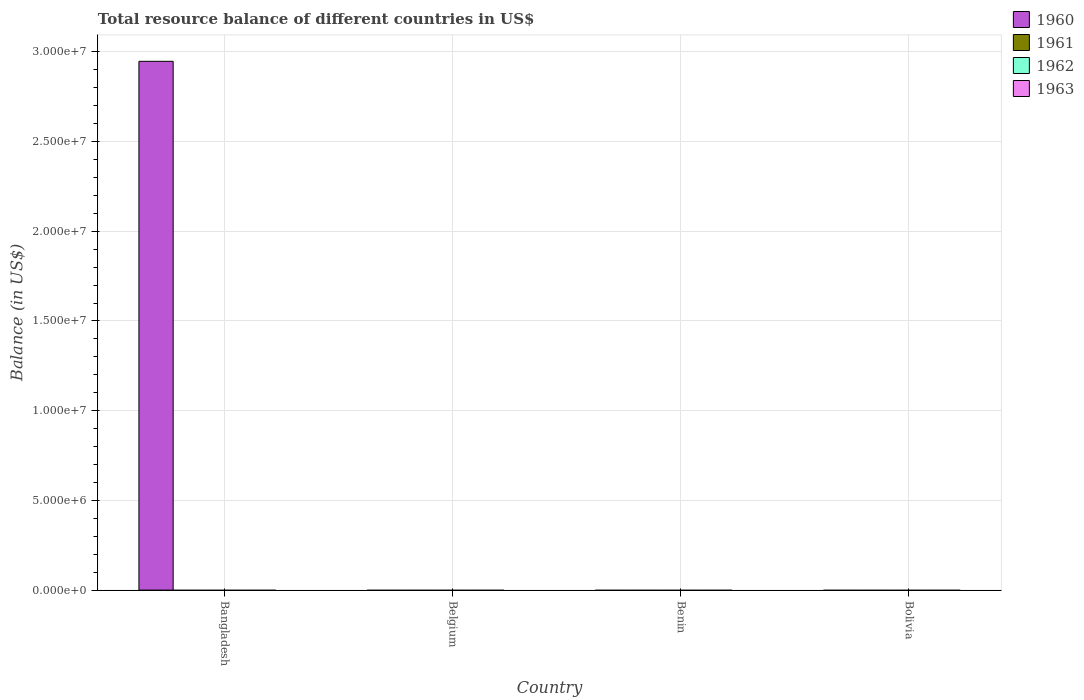How many different coloured bars are there?
Provide a short and direct response. 1. How many bars are there on the 1st tick from the left?
Offer a terse response. 1. How many bars are there on the 1st tick from the right?
Your answer should be very brief. 0. What is the label of the 1st group of bars from the left?
Provide a succinct answer. Bangladesh. In how many cases, is the number of bars for a given country not equal to the number of legend labels?
Keep it short and to the point. 4. What is the total resource balance in 1962 in Bangladesh?
Make the answer very short. 0. Across all countries, what is the maximum total resource balance in 1960?
Provide a short and direct response. 2.95e+07. What is the total total resource balance in 1963 in the graph?
Provide a short and direct response. 0. What is the difference between the total resource balance in 1963 in Belgium and the total resource balance in 1960 in Bolivia?
Ensure brevity in your answer.  0. What is the average total resource balance in 1963 per country?
Provide a short and direct response. 0. What is the difference between the highest and the lowest total resource balance in 1960?
Your response must be concise. 2.95e+07. In how many countries, is the total resource balance in 1961 greater than the average total resource balance in 1961 taken over all countries?
Your response must be concise. 0. Is it the case that in every country, the sum of the total resource balance in 1962 and total resource balance in 1960 is greater than the total resource balance in 1961?
Your answer should be very brief. No. How many bars are there?
Offer a very short reply. 1. Are the values on the major ticks of Y-axis written in scientific E-notation?
Provide a short and direct response. Yes. Does the graph contain grids?
Offer a terse response. Yes. Where does the legend appear in the graph?
Provide a short and direct response. Top right. How many legend labels are there?
Your response must be concise. 4. What is the title of the graph?
Offer a very short reply. Total resource balance of different countries in US$. Does "2008" appear as one of the legend labels in the graph?
Provide a succinct answer. No. What is the label or title of the X-axis?
Provide a short and direct response. Country. What is the label or title of the Y-axis?
Your answer should be compact. Balance (in US$). What is the Balance (in US$) of 1960 in Bangladesh?
Offer a terse response. 2.95e+07. What is the Balance (in US$) of 1961 in Belgium?
Make the answer very short. 0. What is the Balance (in US$) of 1962 in Belgium?
Offer a very short reply. 0. What is the Balance (in US$) in 1961 in Benin?
Your answer should be very brief. 0. What is the Balance (in US$) in 1963 in Benin?
Your answer should be compact. 0. What is the Balance (in US$) in 1960 in Bolivia?
Your answer should be compact. 0. What is the Balance (in US$) in 1961 in Bolivia?
Make the answer very short. 0. What is the Balance (in US$) in 1963 in Bolivia?
Provide a short and direct response. 0. Across all countries, what is the maximum Balance (in US$) of 1960?
Give a very brief answer. 2.95e+07. What is the total Balance (in US$) in 1960 in the graph?
Provide a short and direct response. 2.95e+07. What is the average Balance (in US$) of 1960 per country?
Make the answer very short. 7.37e+06. What is the average Balance (in US$) in 1961 per country?
Offer a terse response. 0. What is the average Balance (in US$) of 1962 per country?
Your answer should be very brief. 0. What is the average Balance (in US$) in 1963 per country?
Provide a succinct answer. 0. What is the difference between the highest and the lowest Balance (in US$) in 1960?
Make the answer very short. 2.95e+07. 